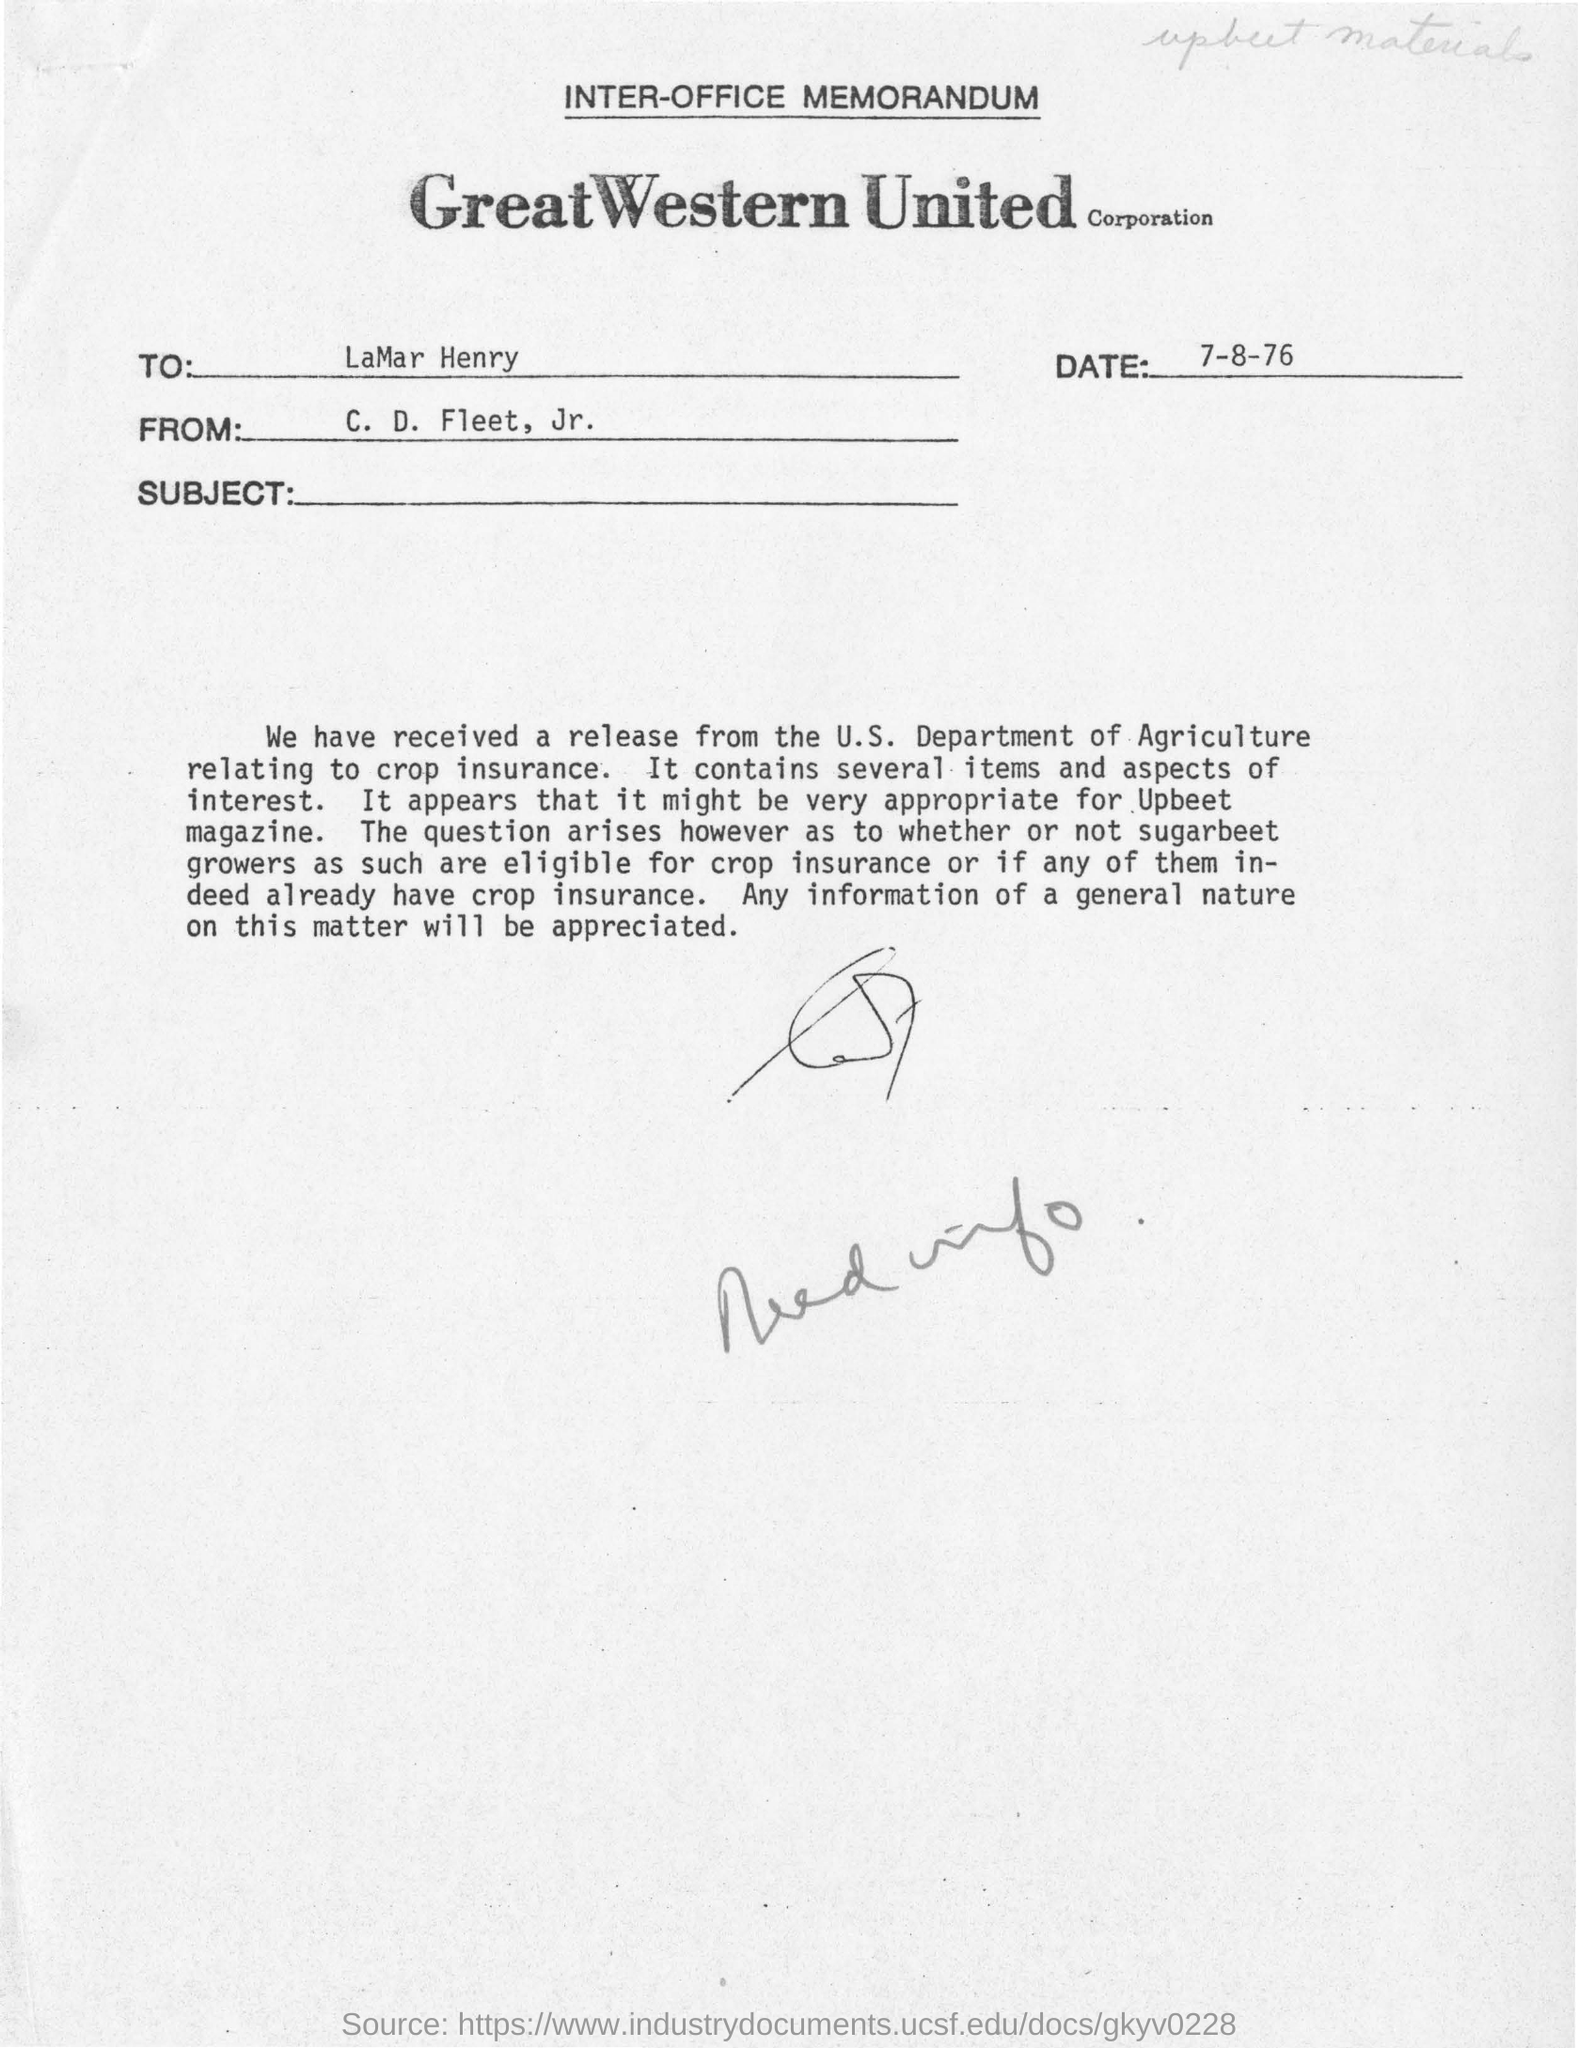What is the date of this document?
Ensure brevity in your answer.  7-8-76. To whom this letter is addressed?
Your answer should be very brief. LaMar Henry. Who is the sender of this letter?
Offer a terse response. C. D. Fleet, Jr. 